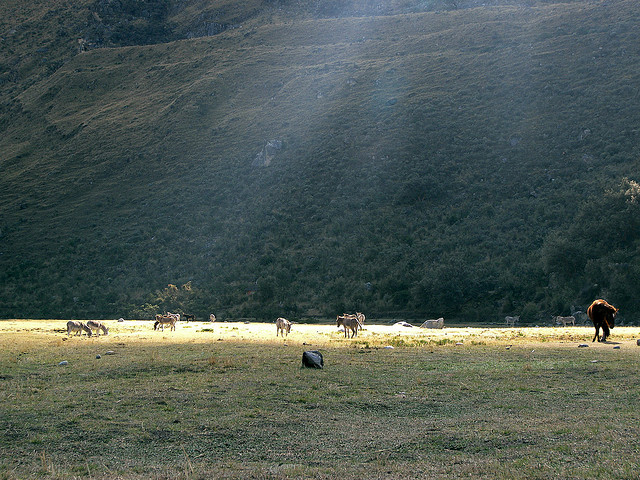What kind of animals are grazing in this field? The animals in the field appear to be horses, enjoying the open space and grass available in this tranquil setting. Where is this place located? Without specific landmarks or signs, it's hard to determine the exact location. However, the landscape suggests it could be a temperate zone with grasslands, possibly in a valley surrounded by mountains. 